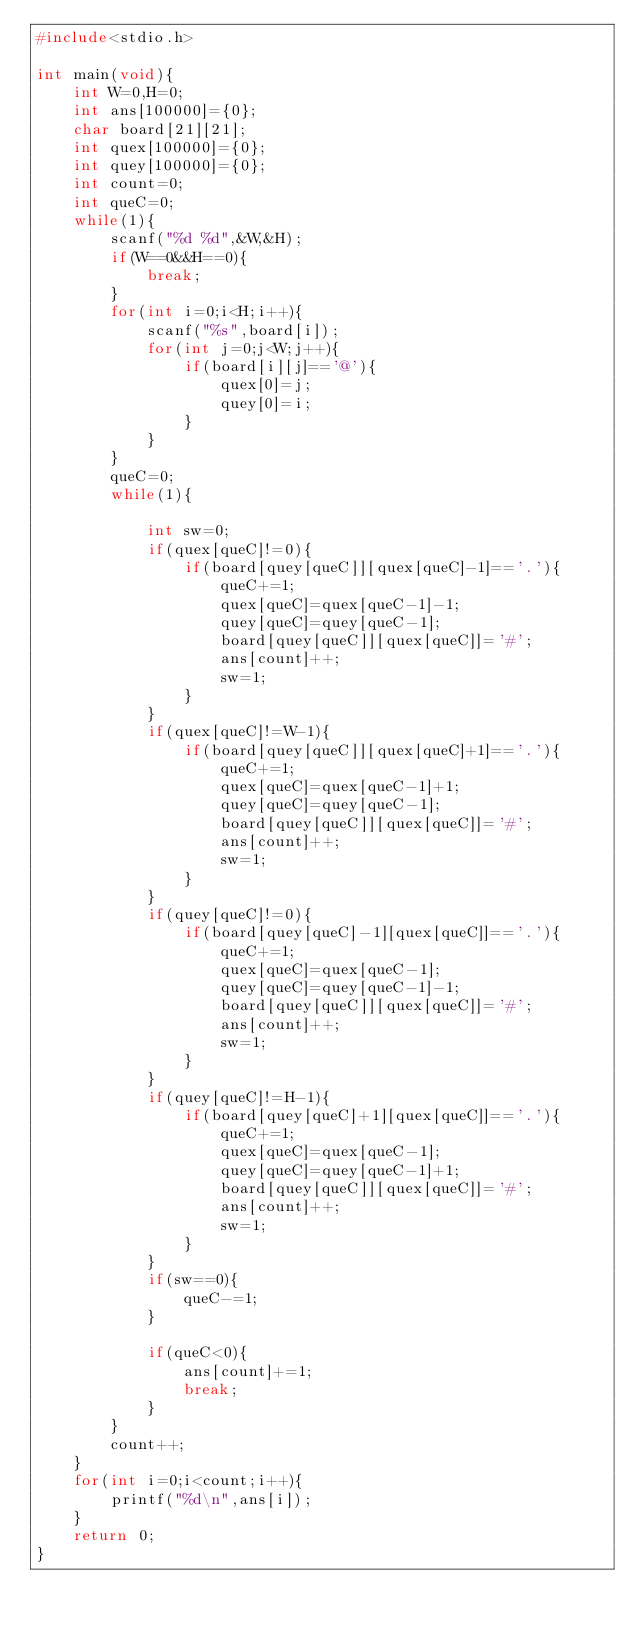<code> <loc_0><loc_0><loc_500><loc_500><_C_>#include<stdio.h>

int main(void){
    int W=0,H=0;
    int ans[100000]={0};
    char board[21][21];
    int quex[100000]={0};
    int quey[100000]={0};
    int count=0;
    int queC=0;
    while(1){
        scanf("%d %d",&W,&H);
        if(W==0&&H==0){
            break;
        }
        for(int i=0;i<H;i++){
            scanf("%s",board[i]);
            for(int j=0;j<W;j++){
                if(board[i][j]=='@'){
                    quex[0]=j;
                    quey[0]=i;
                }
            }
        }
        queC=0;
        while(1){
          
            int sw=0;
            if(quex[queC]!=0){
                if(board[quey[queC]][quex[queC]-1]=='.'){
                    queC+=1;
                    quex[queC]=quex[queC-1]-1;
                    quey[queC]=quey[queC-1];
                    board[quey[queC]][quex[queC]]='#';
                    ans[count]++;
                    sw=1;
                }
            }
            if(quex[queC]!=W-1){
                if(board[quey[queC]][quex[queC]+1]=='.'){
                    queC+=1;
                    quex[queC]=quex[queC-1]+1;
                    quey[queC]=quey[queC-1];
                    board[quey[queC]][quex[queC]]='#';
                    ans[count]++;
                    sw=1;
                }
            }
            if(quey[queC]!=0){
                if(board[quey[queC]-1][quex[queC]]=='.'){
                    queC+=1;
                    quex[queC]=quex[queC-1];
                    quey[queC]=quey[queC-1]-1;
                    board[quey[queC]][quex[queC]]='#';
                    ans[count]++;
                    sw=1;
                }
            }
            if(quey[queC]!=H-1){
                if(board[quey[queC]+1][quex[queC]]=='.'){
                    queC+=1;
                    quex[queC]=quex[queC-1];
                    quey[queC]=quey[queC-1]+1;
                    board[quey[queC]][quex[queC]]='#';
                    ans[count]++;
                    sw=1;
                }
            }
            if(sw==0){
                queC-=1;
            }
           
            if(queC<0){
                ans[count]+=1;
                break;
            }
        }
        count++;
    }
    for(int i=0;i<count;i++){
        printf("%d\n",ans[i]);
    }
    return 0;
}
</code> 